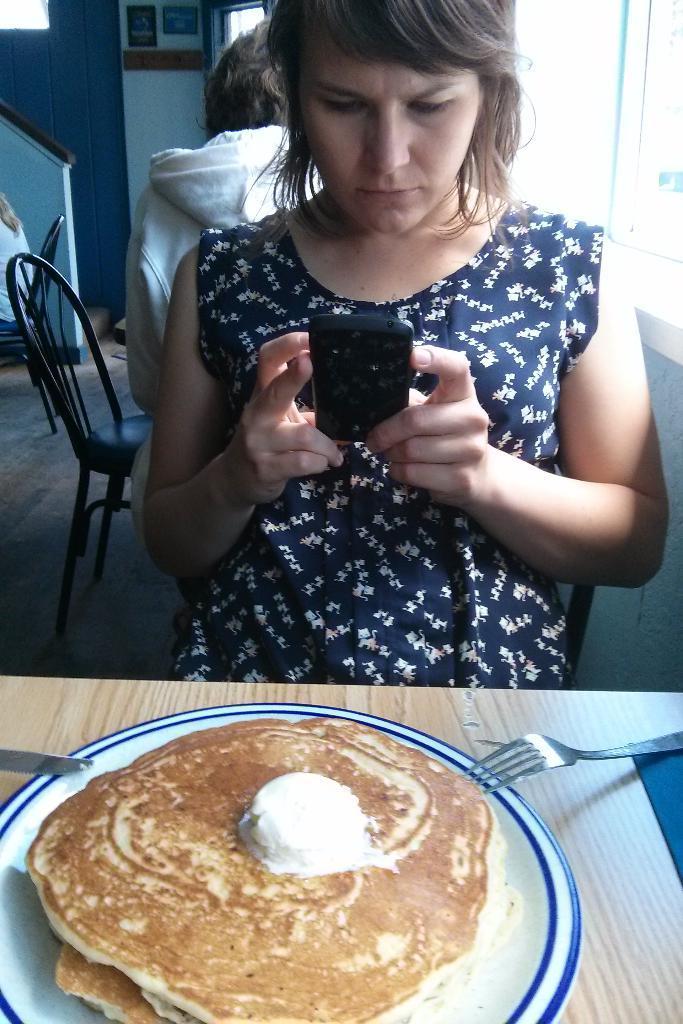Could you give a brief overview of what you see in this image? In this picture we can see food is in the plate, and the plate, fork, knives are on the table, in front of the table a lady is seated on the chair and she is looking into mobile. 